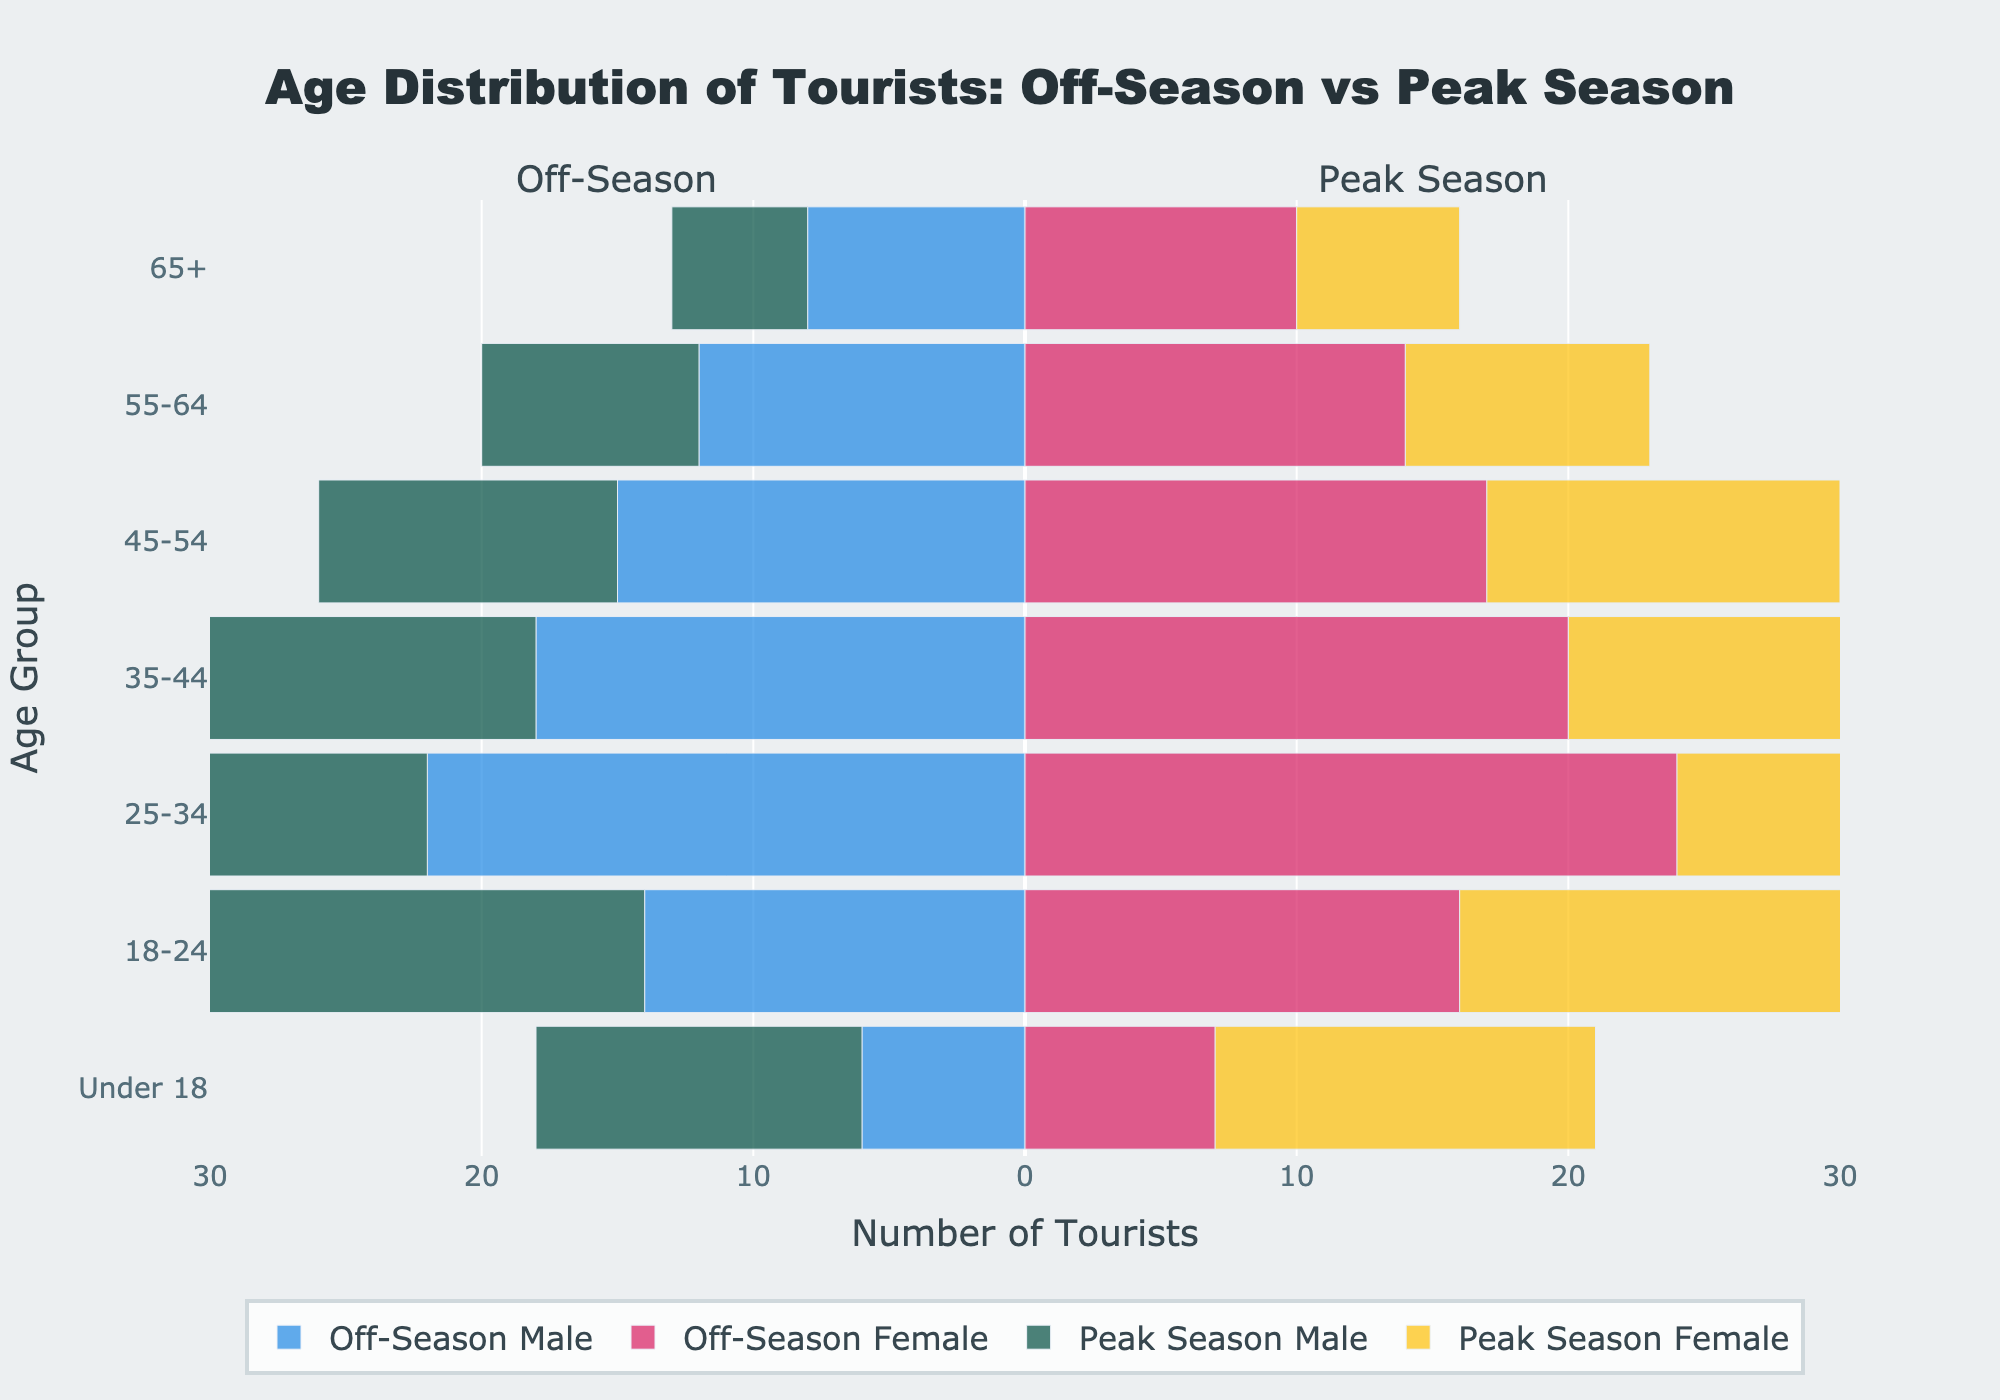What's the age group with the highest number of tourists during the off-season? To find the age group with the highest number of tourists during the off-season, look at the longest bars in the off-season section for both males and females. The 25-34 age group has the longest bars, representing 22 males and 24 females.
Answer: 25-34 How many more tourists are there aged 18-24 during peak season compared to the off-season? During peak season, there are 20 males and 22 females aged 18-24, totaling 42 tourists. In the off-season, there are 14 males and 16 females in the same age group, totaling 30 tourists. The difference is 42 - 30 = 12 tourists.
Answer: 12 Which gender and season combination has the lowest number of tourists in the 65+ age group? Examine the length of the bars for each gender and season combination in the 65+ age group. The shortest bar is for males during peak season, with a value of 5.
Answer: Males in peak season Compare the number of male tourists aged 35-44 during off-season and peak season. Which season has more tourists? Look at the bars for males aged 35-44 in both seasons. During the off-season, there are 18 males; during peak season, there are 22 males. Peak season has more tourists.
Answer: Peak season What's the overall trend in the number of tourists as the age group increases for both seasons? For both off-season and peak season, as the age group increases, the number of tourists generally decreases. This trend can be observed by looking at the bars for each subsequent age group.
Answer: Decreasing trend What is the total number of tourists Under 18 during peak season? Add the number of male and female tourists under 18 during peak season. There are 12 males and 14 females, totaling 12 + 14 = 26 tourists.
Answer: 26 Which age group sees the largest difference in the number of female tourists between off-season and peak season? Evaluate the differences in the number of female tourists for each age group. The largest difference is found in the 25-34 age group, with 24 (off-season) and 30 (peak season), a difference of 30 - 24 = 6.
Answer: 25-34 In which age group and season combination do female tourists exceed male tourists by the largest margin? Compare the difference between female and male tourists in each age group and season. In the 35-44 age group during the peak season, females (24) exceed males (22) by the largest margin of 24 - 22 = 2 tourists.
Answer: 35-44, Peak Season What is the combined number of off-season and peak season tourists in the 55-64 age group? For the 55-64 age group, add the numbers of males and females during both off-season and peak season: Off-season male (12) + Off-season female (14) + Peak season male (8) + Peak season female (9) = 12 + 14 + 8 + 9 = 43.
Answer: 43 Which gender has more tourists overall in the peak season across all age groups? Sum up the total number of male and female tourists across all age groups in the peak season. Females: 6 + 9 + 13 + 24 + 30 + 22 + 14 = 118. Males: 5 + 8 + 11 + 22 + 28 + 20 + 12 = 106. Females have more tourists.
Answer: Females 